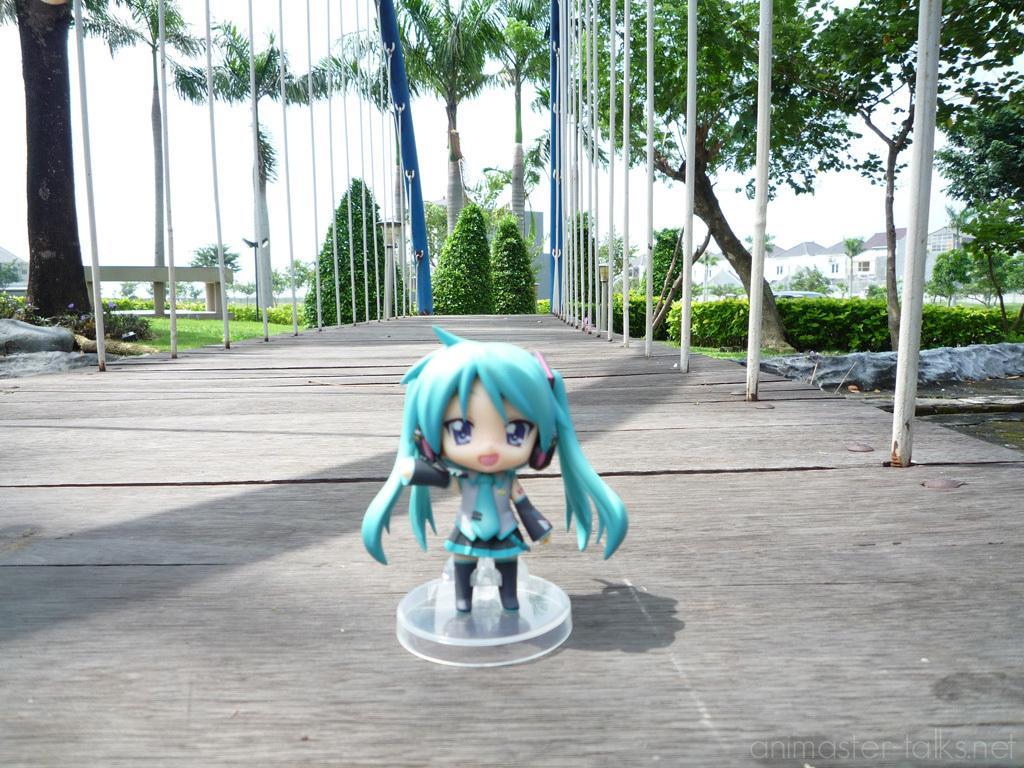Could you give a brief overview of what you see in this image? This image is taken outdoors. At the bottom of the image there is a wooden platform. In the background there are a few trees, plants, houses, poles and a ground with grass on it. In the middle of the image there is a toy on the wooden platform. At the top of the image there is a sky. 